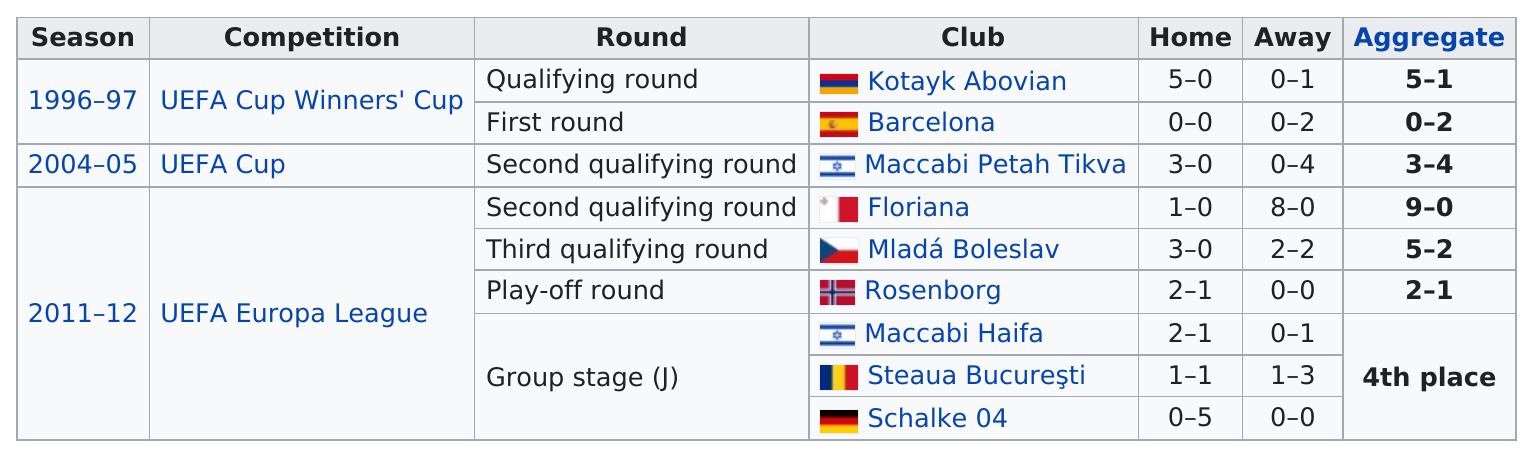Highlight a few significant elements in this photo. The season, competition, round, club, home team, away team, and aggregate score of each match are listed at the top of the table. Kotayk Abovian has the highest home score among all clubs. There are 3 listed seasons. Two teams, Kotayk Abovian and Rosenborg, had only one loss each. Club Kotayk Abovian has achieved a total of 5 wins. 